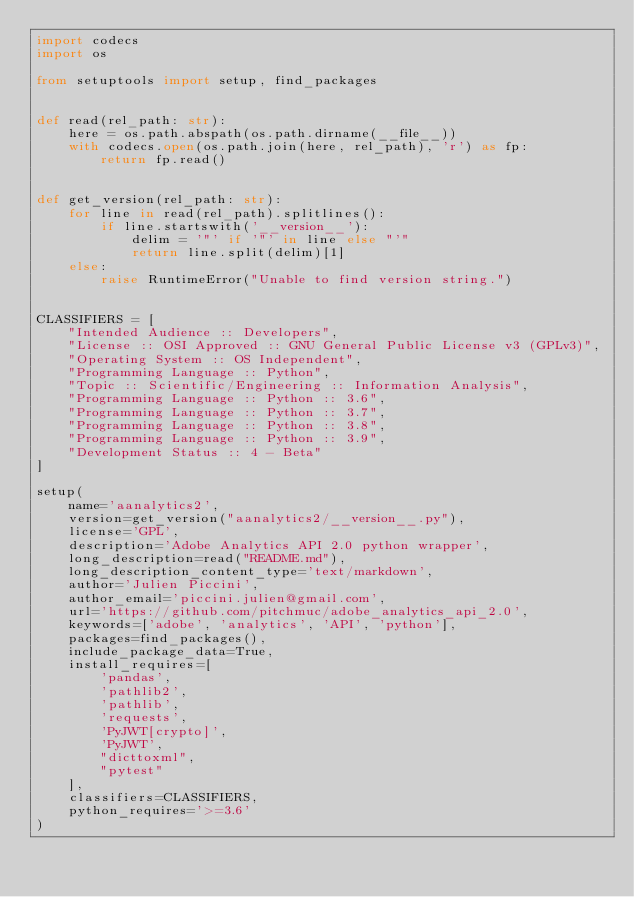Convert code to text. <code><loc_0><loc_0><loc_500><loc_500><_Python_>import codecs
import os

from setuptools import setup, find_packages


def read(rel_path: str):
    here = os.path.abspath(os.path.dirname(__file__))
    with codecs.open(os.path.join(here, rel_path), 'r') as fp:
        return fp.read()


def get_version(rel_path: str):
    for line in read(rel_path).splitlines():
        if line.startswith('__version__'):
            delim = '"' if '"' in line else "'"
            return line.split(delim)[1]
    else:
        raise RuntimeError("Unable to find version string.")


CLASSIFIERS = [
    "Intended Audience :: Developers",
    "License :: OSI Approved :: GNU General Public License v3 (GPLv3)",
    "Operating System :: OS Independent",
    "Programming Language :: Python",
    "Topic :: Scientific/Engineering :: Information Analysis",
    "Programming Language :: Python :: 3.6",
    "Programming Language :: Python :: 3.7",
    "Programming Language :: Python :: 3.8",
    "Programming Language :: Python :: 3.9",
    "Development Status :: 4 - Beta"
]

setup(
    name='aanalytics2',
    version=get_version("aanalytics2/__version__.py"),
    license='GPL',
    description='Adobe Analytics API 2.0 python wrapper',
    long_description=read("README.md"),
    long_description_content_type='text/markdown',
    author='Julien Piccini',
    author_email='piccini.julien@gmail.com',
    url='https://github.com/pitchmuc/adobe_analytics_api_2.0',
    keywords=['adobe', 'analytics', 'API', 'python'],
    packages=find_packages(),
    include_package_data=True,
    install_requires=[
        'pandas',
        'pathlib2',
        'pathlib',
        'requests',
        'PyJWT[crypto]',
        'PyJWT',
        "dicttoxml",
        "pytest"
    ],
    classifiers=CLASSIFIERS,
    python_requires='>=3.6'
)
</code> 